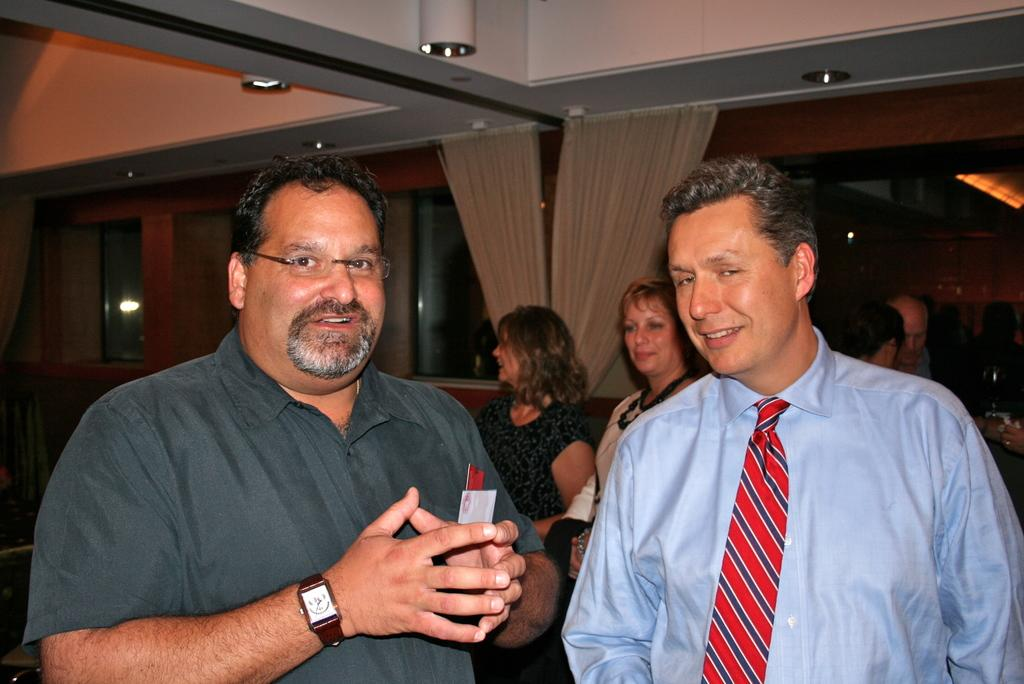How many men are standing in the front of the image? There are 2 men standing in the front of the image. Can you describe the other people visible in the image? There are other people visible in the image, but their specific number or characteristics are not mentioned in the provided facts. What can be seen hanging in the image? There are curtains in the image. What type of throat lozenge is being offered to the monkey in the image? There is no monkey or throat lozenge present in the image. What is the purpose of the whip in the image? There is no whip present in the image. 